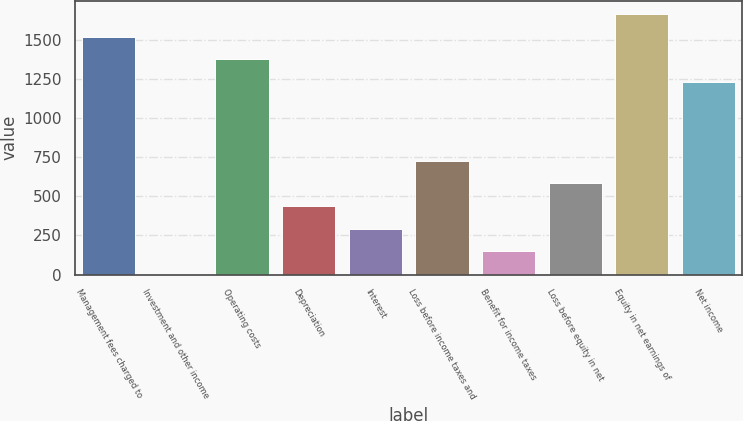Convert chart. <chart><loc_0><loc_0><loc_500><loc_500><bar_chart><fcel>Management fees charged to<fcel>Investment and other income<fcel>Operating costs<fcel>Depreciation<fcel>Interest<fcel>Loss before income taxes and<fcel>Benefit for income taxes<fcel>Loss before equity in net<fcel>Equity in net earnings of<fcel>Net income<nl><fcel>1520.6<fcel>3<fcel>1375.8<fcel>437.4<fcel>292.6<fcel>727<fcel>147.8<fcel>582.2<fcel>1665.4<fcel>1231<nl></chart> 